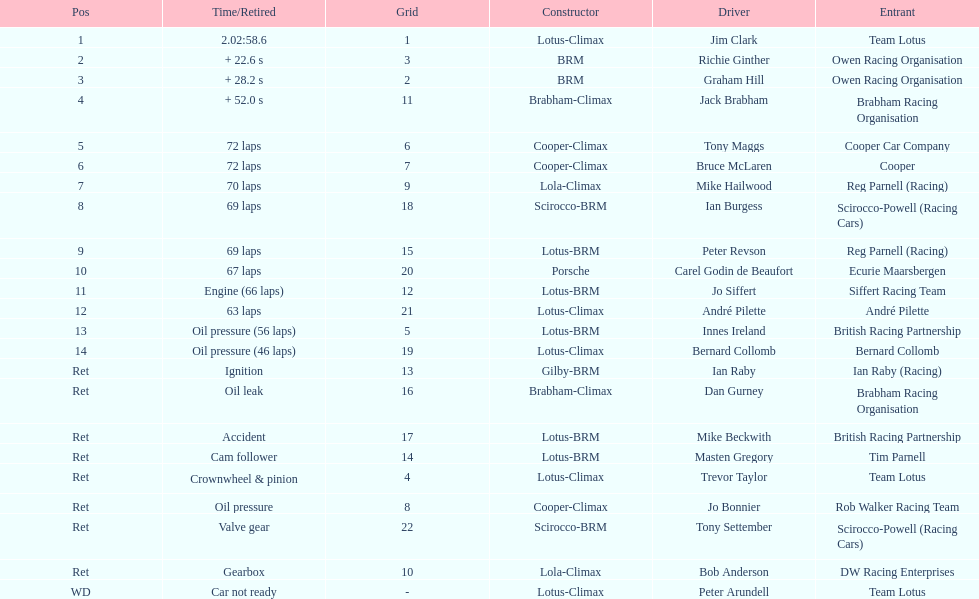How many different drivers are listed? 23. 